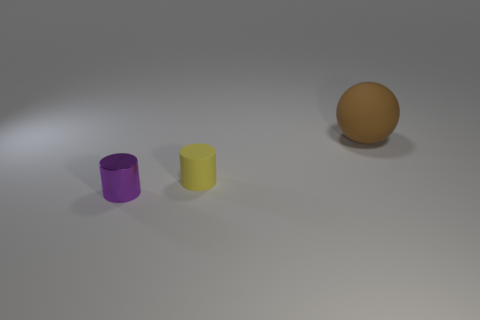What colors are the cylinders present in the image? There are two cylinders; one is purple, and the other is yellow. 